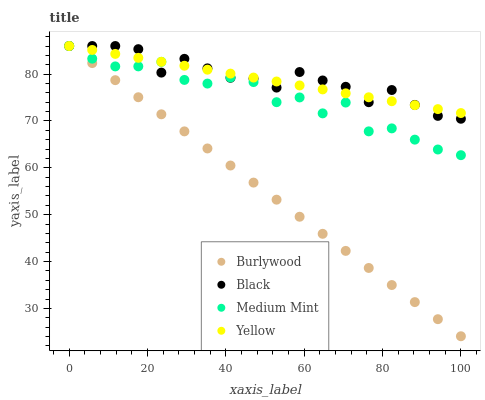Does Burlywood have the minimum area under the curve?
Answer yes or no. Yes. Does Black have the maximum area under the curve?
Answer yes or no. Yes. Does Medium Mint have the minimum area under the curve?
Answer yes or no. No. Does Medium Mint have the maximum area under the curve?
Answer yes or no. No. Is Burlywood the smoothest?
Answer yes or no. Yes. Is Medium Mint the roughest?
Answer yes or no. Yes. Is Black the smoothest?
Answer yes or no. No. Is Black the roughest?
Answer yes or no. No. Does Burlywood have the lowest value?
Answer yes or no. Yes. Does Medium Mint have the lowest value?
Answer yes or no. No. Does Yellow have the highest value?
Answer yes or no. Yes. Does Yellow intersect Black?
Answer yes or no. Yes. Is Yellow less than Black?
Answer yes or no. No. Is Yellow greater than Black?
Answer yes or no. No. 